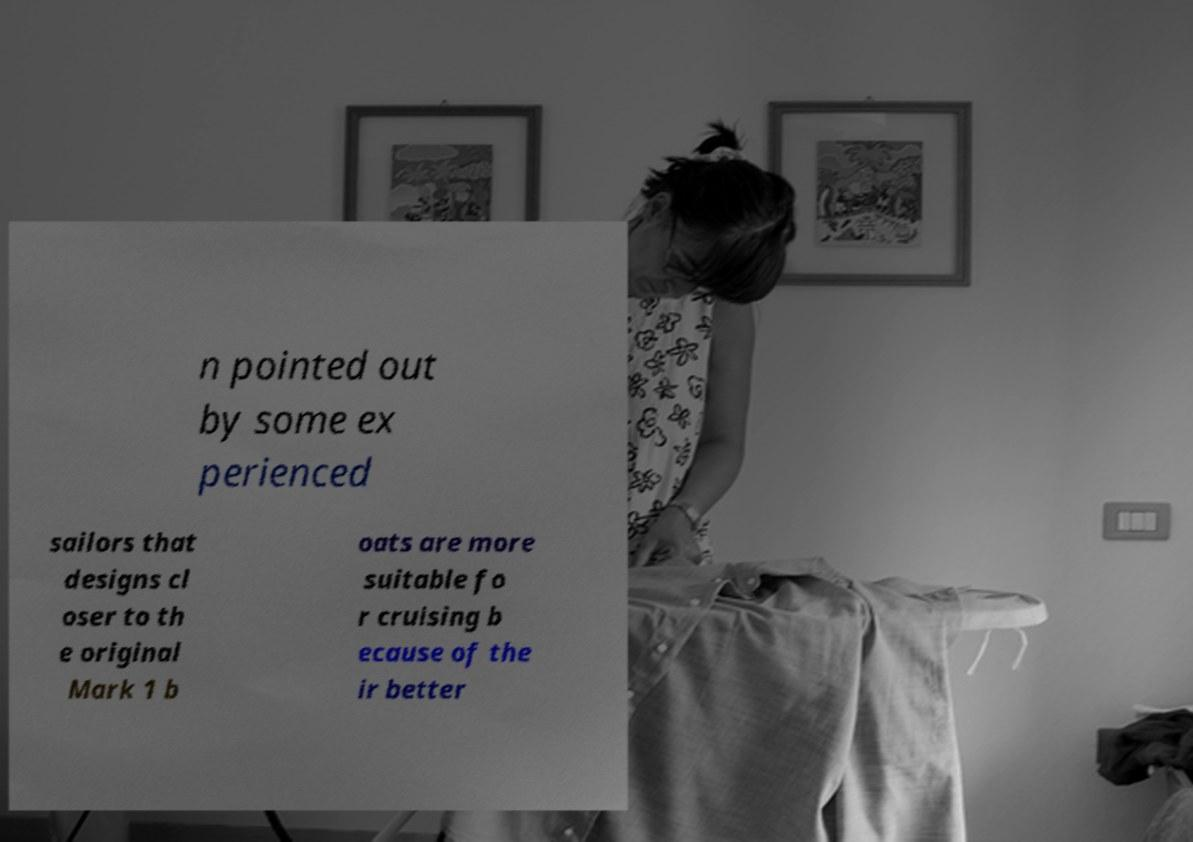There's text embedded in this image that I need extracted. Can you transcribe it verbatim? n pointed out by some ex perienced sailors that designs cl oser to th e original Mark 1 b oats are more suitable fo r cruising b ecause of the ir better 